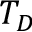Convert formula to latex. <formula><loc_0><loc_0><loc_500><loc_500>T _ { D }</formula> 